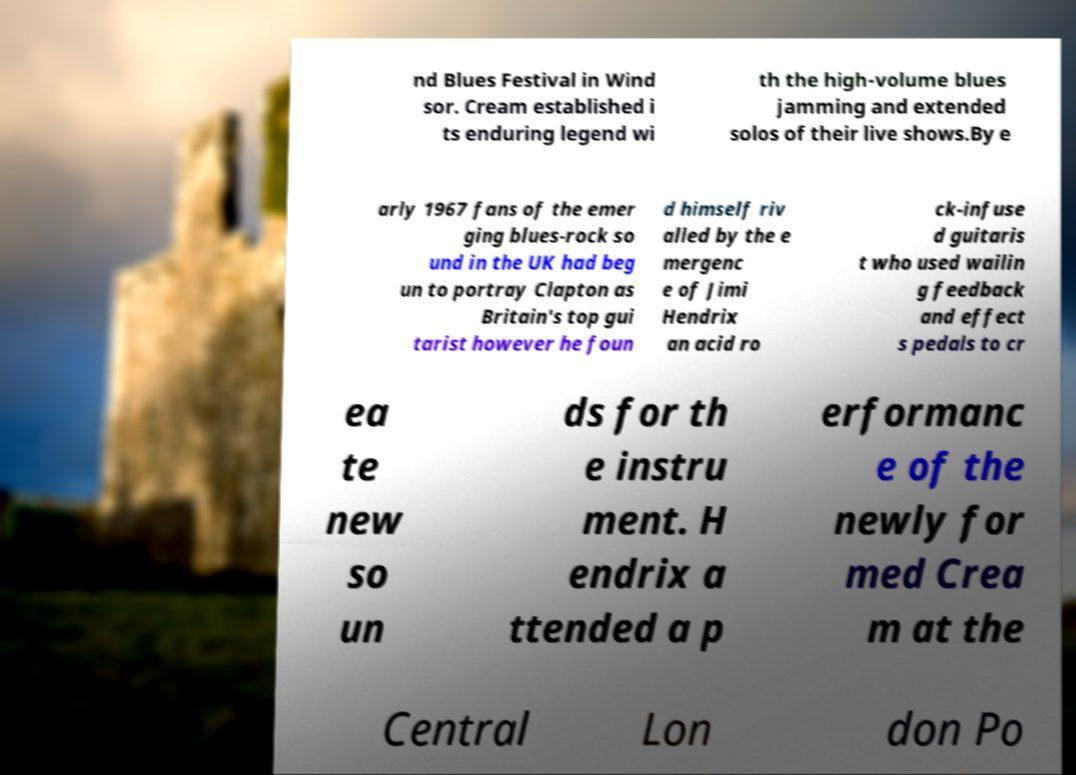I need the written content from this picture converted into text. Can you do that? nd Blues Festival in Wind sor. Cream established i ts enduring legend wi th the high-volume blues jamming and extended solos of their live shows.By e arly 1967 fans of the emer ging blues-rock so und in the UK had beg un to portray Clapton as Britain's top gui tarist however he foun d himself riv alled by the e mergenc e of Jimi Hendrix an acid ro ck-infuse d guitaris t who used wailin g feedback and effect s pedals to cr ea te new so un ds for th e instru ment. H endrix a ttended a p erformanc e of the newly for med Crea m at the Central Lon don Po 